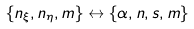<formula> <loc_0><loc_0><loc_500><loc_500>\{ n _ { \xi } , n _ { \eta } , m \} \leftrightarrow \{ \alpha , n , s , m \}</formula> 